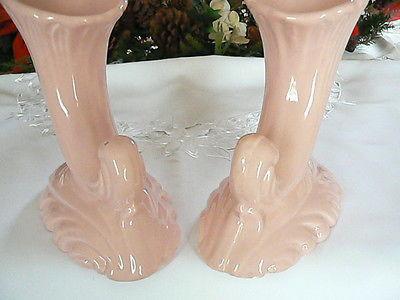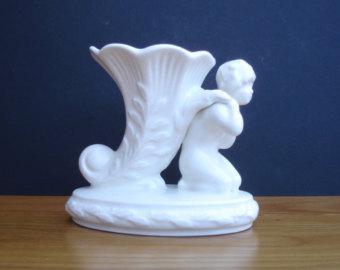The first image is the image on the left, the second image is the image on the right. For the images shown, is this caption "Two vases in one image are a matched set, while a single vase in the second image is solid white on an oval base." true? Answer yes or no. Yes. The first image is the image on the left, the second image is the image on the right. Examine the images to the left and right. Is the description "An image shows a matched pair of white vases." accurate? Answer yes or no. No. 